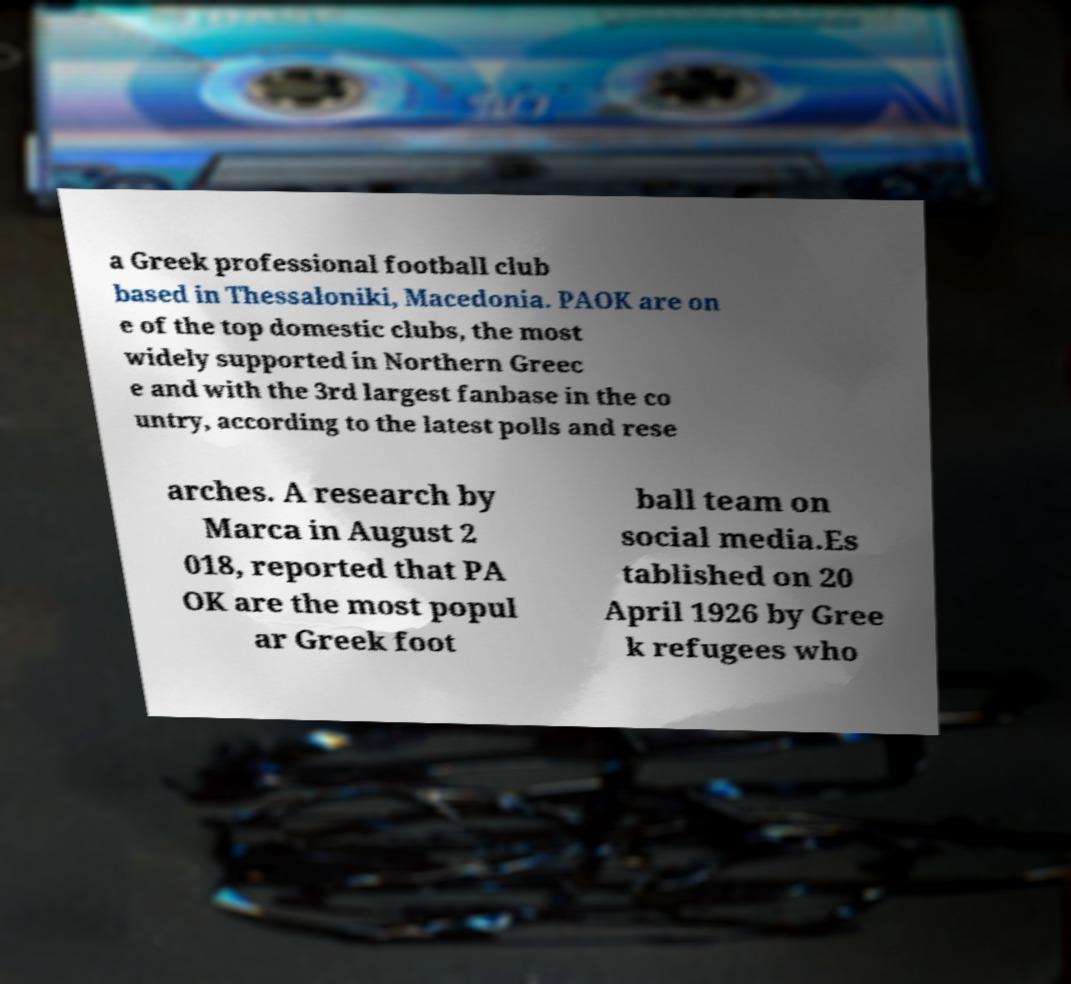For documentation purposes, I need the text within this image transcribed. Could you provide that? a Greek professional football club based in Thessaloniki, Macedonia. PAOK are on e of the top domestic clubs, the most widely supported in Northern Greec e and with the 3rd largest fanbase in the co untry, according to the latest polls and rese arches. A research by Marca in August 2 018, reported that PA OK are the most popul ar Greek foot ball team on social media.Es tablished on 20 April 1926 by Gree k refugees who 